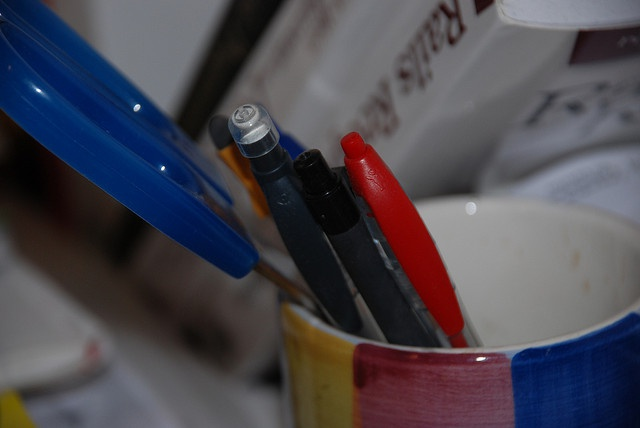Describe the objects in this image and their specific colors. I can see cup in navy, gray, and maroon tones and scissors in navy, black, gray, and darkblue tones in this image. 